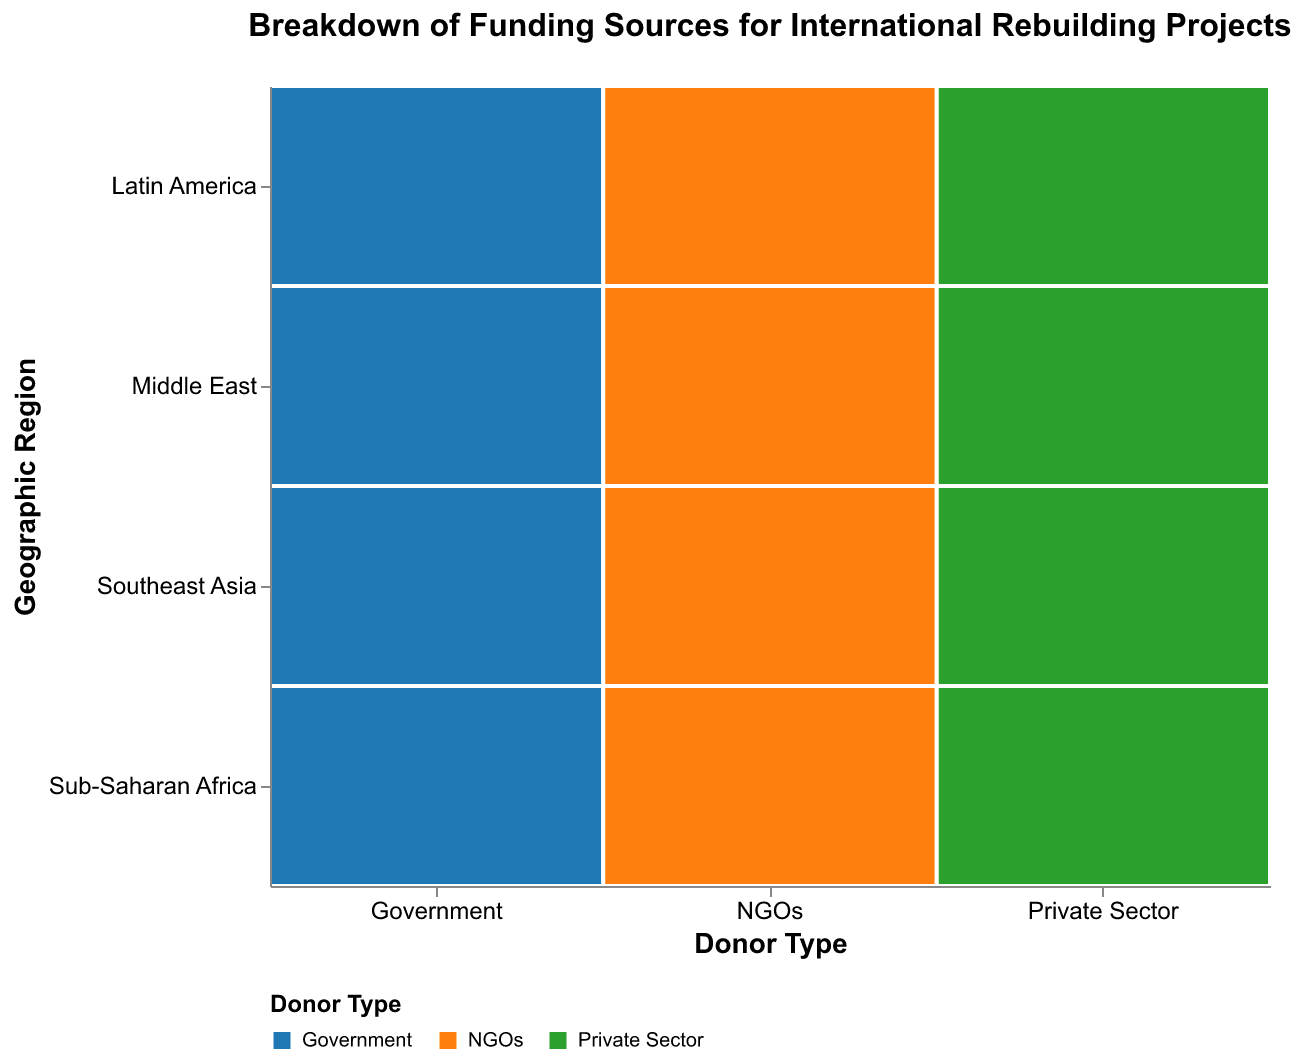Which donor type provides the most funding to the Middle East? By looking at the color and size of rectangles in the Middle East row, we see that funding from the Government is the largest among the three donor types.
Answer: Government Which geographic region receives the most funding from NGOs? By comparing the sizes of rectangles related to NGOs (orange) across all geographic regions, we notice that the rectangle in Sub-Saharan Africa is the largest.
Answer: Sub-Saharan Africa What is the total funding amount from the Private Sector across all geographic regions? Add up the funding amounts from the Private Sector in each region: 1,000,000,000 (Southeast Asia) + 700,000,000 (Sub-Saharan Africa) + 1,500,000,000 (Middle East) + 900,000,000 (Latin America) = 4,100,000,000.
Answer: 4,100,000,000 How does funding to Southeast Asia from the Private Sector compare to that from NGOs? The size of the rectangle for the Private Sector in Southeast Asia (green) is larger than that of the NGOs (orange), indicating higher funding from the Private Sector.
Answer: Private Sector funding is higher Which geographic region receives the least funding from the Government? By comparing the sizes of blue rectangles in different regions, the one in Latin America is the smallest.
Answer: Latin America Calculate the difference in funding amounts between Sub-Saharan Africa and Latin America from NGOs. Sub-Saharan Africa receives 1,200,000,000, while Latin America receives 400,000,000. The difference is 1,200,000,000 - 400,000,000 = 800,000,000.
Answer: 800,000,000 Which donor type provides the least total funding across all geographic regions? Sum the funding amounts for each donor type: Government (2,500,000,000 + 1,800,000,000 + 3,200,000,000 + 1,500,000,000 = 9,000,000,000), NGOs (800,000,000 + 1,200,000,000 + 600,000,000 + 400,000,000 = 3,000,000,000), Private Sector (1,000,000,000 + 700,000,000 + 1,500,000,000 + 900,000,000 = 4,100,000,000). NGOs provide the least total funding.
Answer: NGOs What is the proportion of funding from the Private Sector to the total funding for Sub-Saharan Africa? The total funding for Sub-Saharan Africa is the sum of the funding amount from all donor types: 1,800,000,000 (Government) + 1,200,000,000 (NGOs) + 700,000,000 (Private Sector) = 3,700,000,000. The proportion from the Private Sector is 700,000,000 / 3,700,000,000 ≈ 0.189 or 18.9%.
Answer: 18.9% 